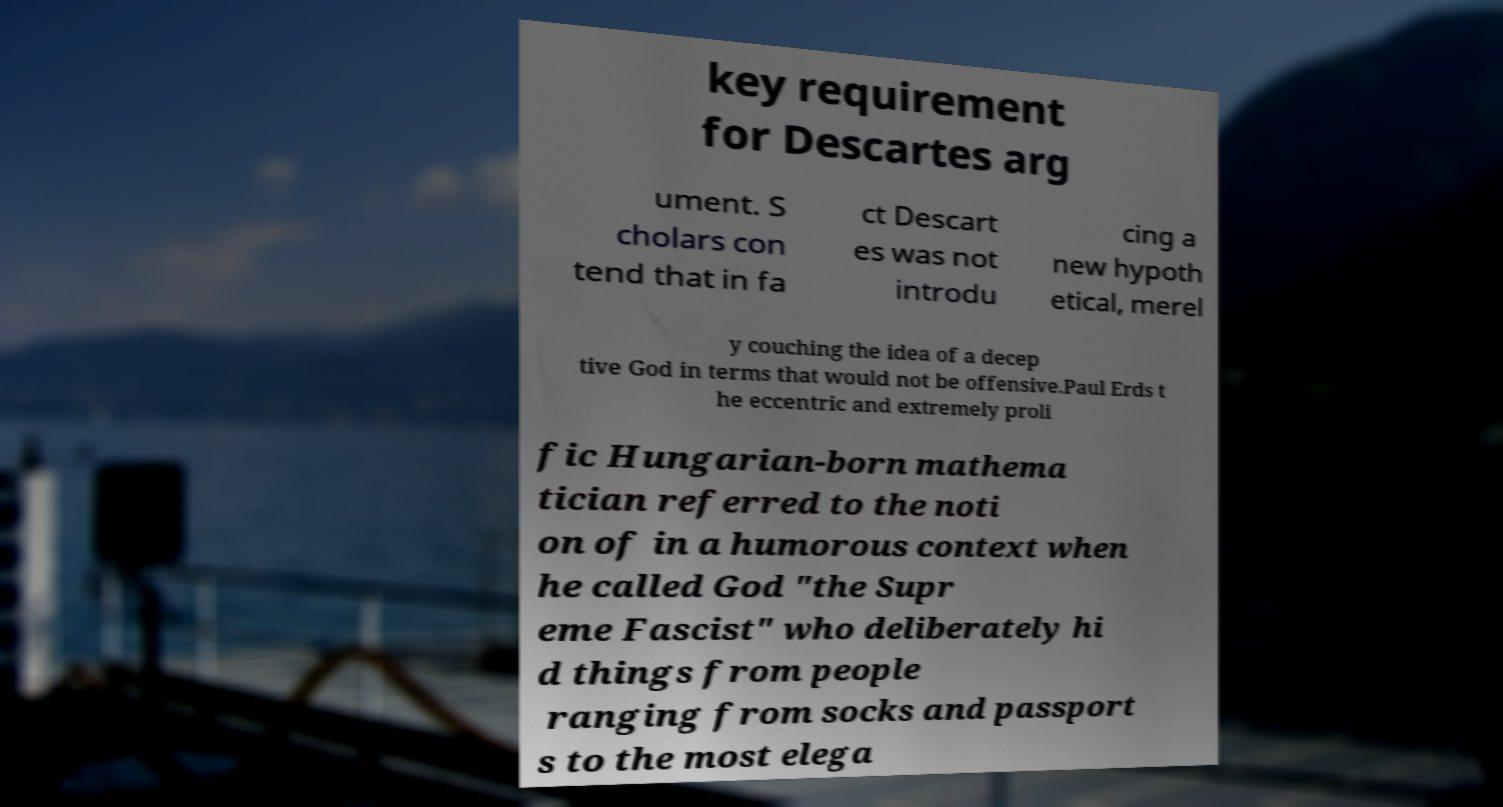Could you assist in decoding the text presented in this image and type it out clearly? key requirement for Descartes arg ument. S cholars con tend that in fa ct Descart es was not introdu cing a new hypoth etical, merel y couching the idea of a decep tive God in terms that would not be offensive.Paul Erds t he eccentric and extremely proli fic Hungarian-born mathema tician referred to the noti on of in a humorous context when he called God "the Supr eme Fascist" who deliberately hi d things from people ranging from socks and passport s to the most elega 